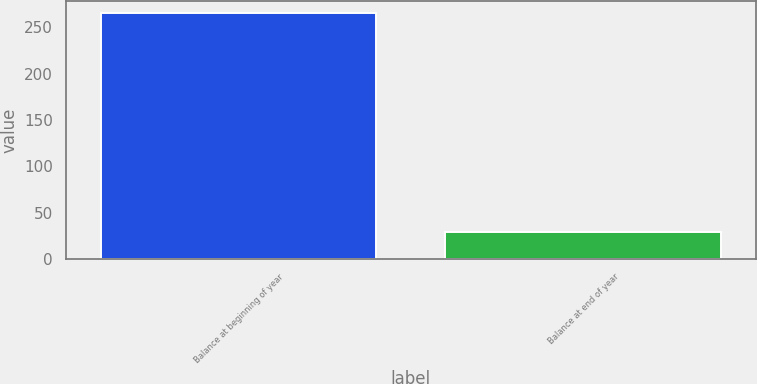Convert chart to OTSL. <chart><loc_0><loc_0><loc_500><loc_500><bar_chart><fcel>Balance at beginning of year<fcel>Balance at end of year<nl><fcel>265<fcel>29<nl></chart> 